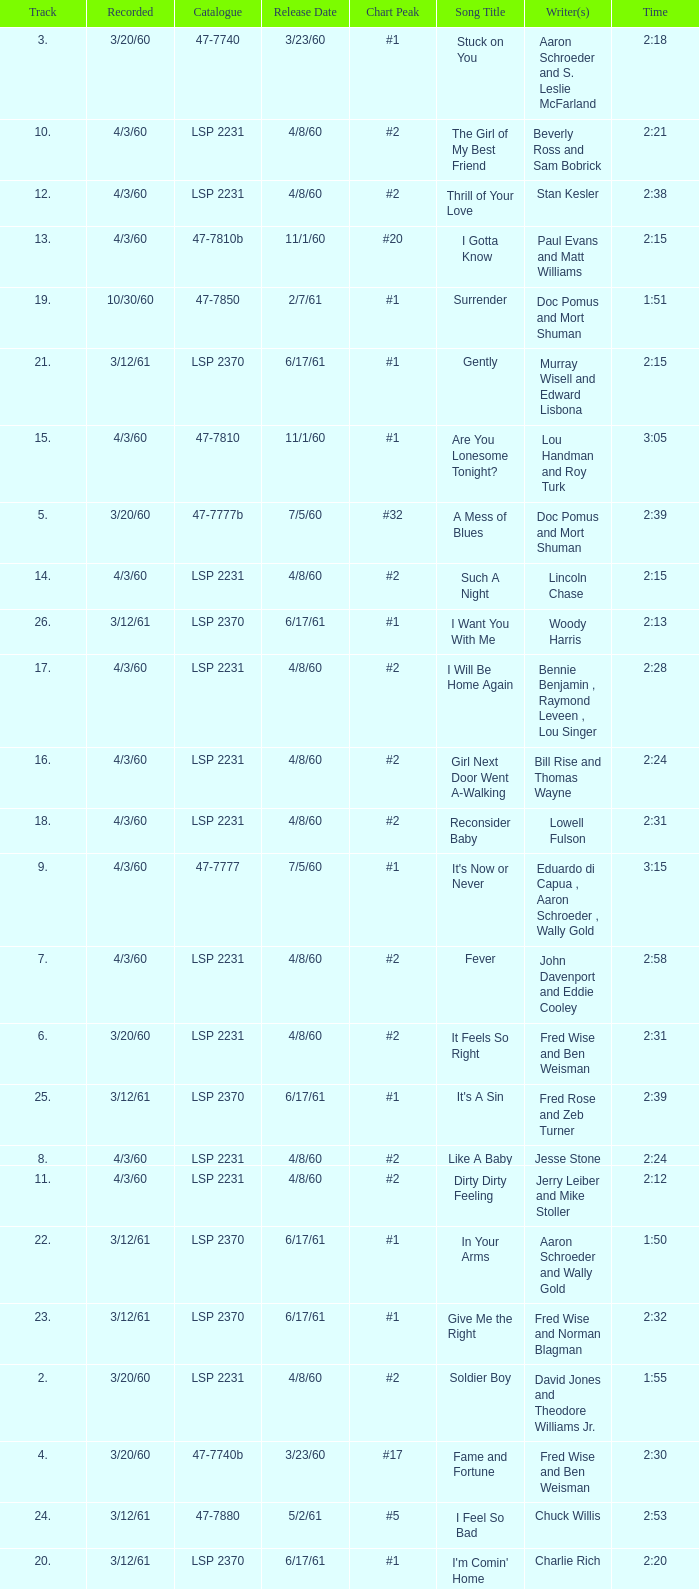Concerning songs with track numbers under 17 and catalogues of lsp 2231, who are the creator(s)? Otis Blackwell, David Jones and Theodore Williams Jr., Fred Wise and Ben Weisman, John Davenport and Eddie Cooley, Jesse Stone, Beverly Ross and Sam Bobrick, Jerry Leiber and Mike Stoller, Stan Kesler, Lincoln Chase, Bill Rise and Thomas Wayne. 